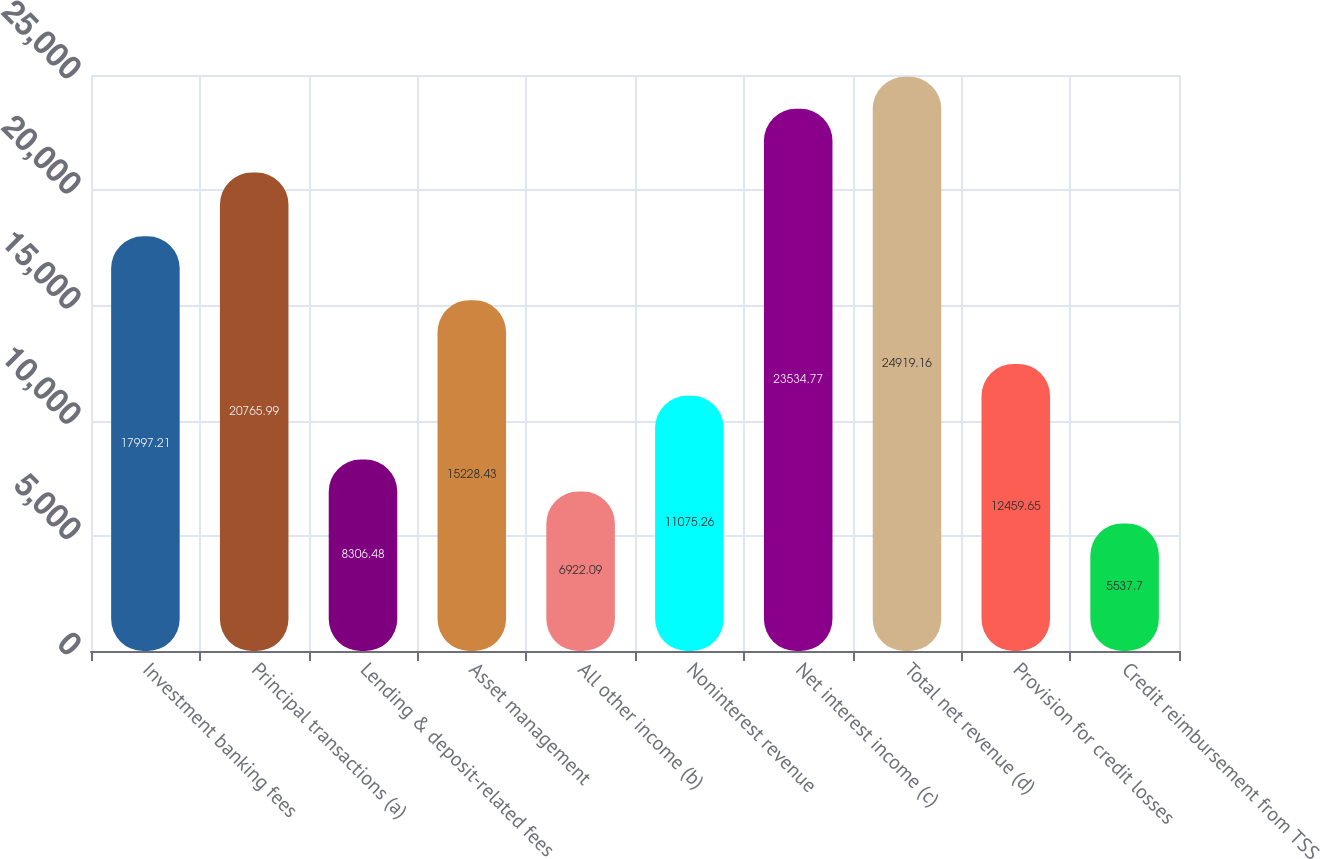Convert chart to OTSL. <chart><loc_0><loc_0><loc_500><loc_500><bar_chart><fcel>Investment banking fees<fcel>Principal transactions (a)<fcel>Lending & deposit-related fees<fcel>Asset management<fcel>All other income (b)<fcel>Noninterest revenue<fcel>Net interest income (c)<fcel>Total net revenue (d)<fcel>Provision for credit losses<fcel>Credit reimbursement from TSS<nl><fcel>17997.2<fcel>20766<fcel>8306.48<fcel>15228.4<fcel>6922.09<fcel>11075.3<fcel>23534.8<fcel>24919.2<fcel>12459.6<fcel>5537.7<nl></chart> 